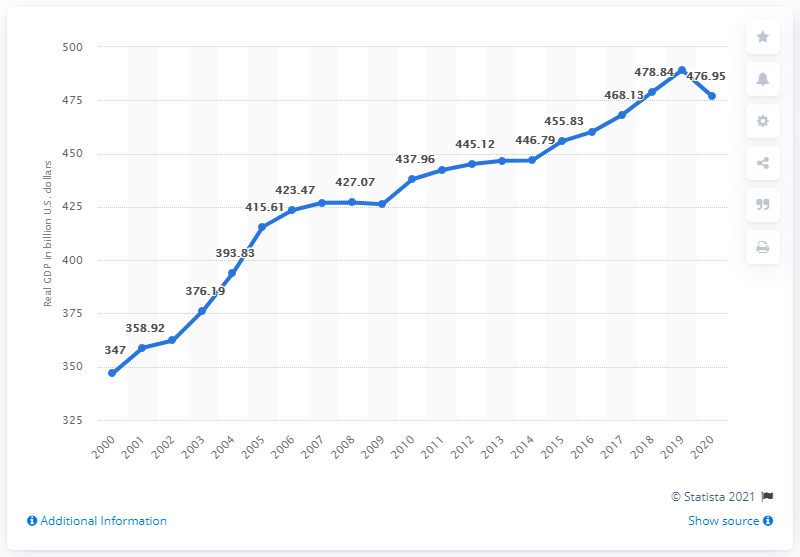Outline some significant characteristics in this image. In 2018, Virginia's Gross Domestic Product (GDP) was 489.17 billion dollars. In 2020, the Gross Domestic Product (GDP) of the state of Virginia was 476.95. 